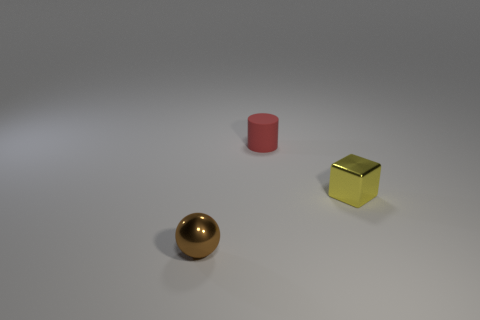Are there any other things that have the same material as the tiny red thing?
Offer a terse response. No. What size is the object in front of the metal thing that is behind the sphere?
Give a very brief answer. Small. Are there an equal number of tiny red matte cylinders that are left of the tiny ball and cubes?
Provide a succinct answer. No. What number of other objects are there of the same color as the rubber cylinder?
Provide a short and direct response. 0. Are there fewer tiny shiny cubes that are to the left of the small brown metal object than gray shiny things?
Your response must be concise. No. Is there a rubber thing of the same size as the yellow metal block?
Your answer should be compact. Yes. How many yellow metal cubes are in front of the tiny thing to the right of the red matte cylinder?
Your response must be concise. 0. There is a metal object on the right side of the metal thing that is on the left side of the tiny yellow shiny cube; what is its color?
Your answer should be very brief. Yellow. There is a object that is in front of the red matte cylinder and on the right side of the brown metal object; what material is it?
Make the answer very short. Metal. Does the metal thing to the left of the yellow shiny object have the same shape as the tiny yellow object?
Keep it short and to the point. No. 